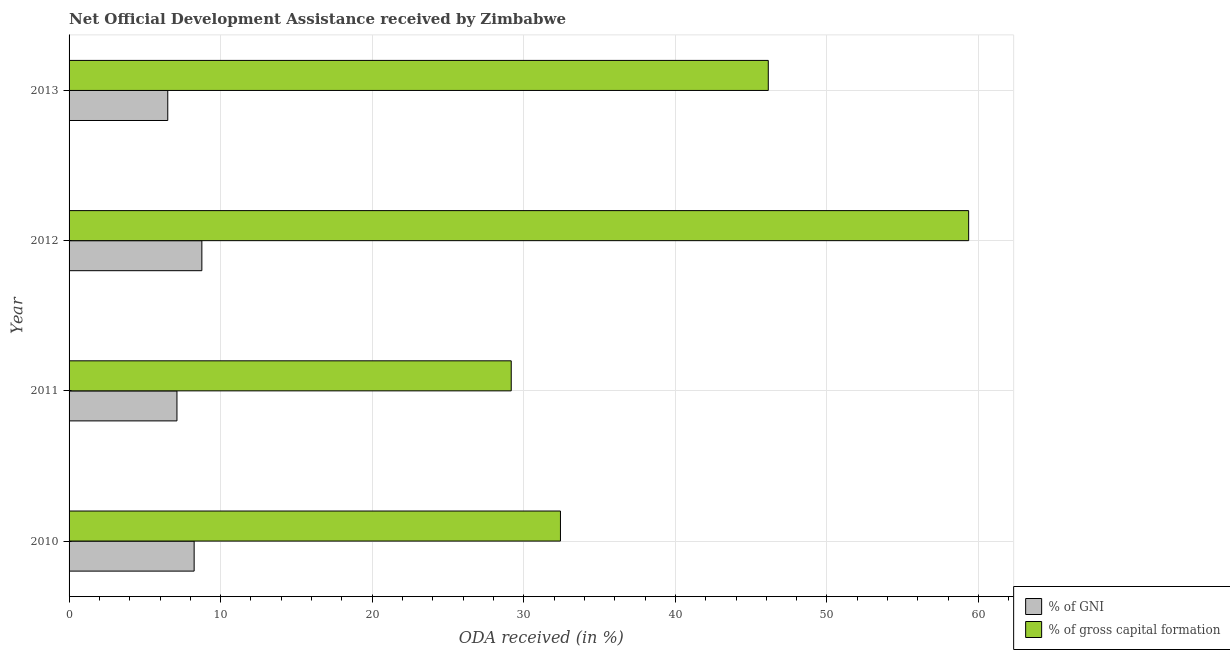How many groups of bars are there?
Make the answer very short. 4. Are the number of bars per tick equal to the number of legend labels?
Your answer should be compact. Yes. How many bars are there on the 1st tick from the bottom?
Your response must be concise. 2. In how many cases, is the number of bars for a given year not equal to the number of legend labels?
Provide a short and direct response. 0. What is the oda received as percentage of gni in 2013?
Make the answer very short. 6.51. Across all years, what is the maximum oda received as percentage of gni?
Provide a short and direct response. 8.76. Across all years, what is the minimum oda received as percentage of gross capital formation?
Provide a succinct answer. 29.17. In which year was the oda received as percentage of gross capital formation maximum?
Your answer should be compact. 2012. In which year was the oda received as percentage of gross capital formation minimum?
Provide a succinct answer. 2011. What is the total oda received as percentage of gross capital formation in the graph?
Give a very brief answer. 167.07. What is the difference between the oda received as percentage of gross capital formation in 2010 and that in 2013?
Keep it short and to the point. -13.71. What is the difference between the oda received as percentage of gross capital formation in 2010 and the oda received as percentage of gni in 2012?
Your answer should be compact. 23.66. What is the average oda received as percentage of gni per year?
Your answer should be very brief. 7.66. In the year 2013, what is the difference between the oda received as percentage of gross capital formation and oda received as percentage of gni?
Offer a terse response. 39.62. In how many years, is the oda received as percentage of gross capital formation greater than 22 %?
Provide a succinct answer. 4. What is the ratio of the oda received as percentage of gni in 2010 to that in 2011?
Give a very brief answer. 1.16. What is the difference between the highest and the second highest oda received as percentage of gni?
Ensure brevity in your answer.  0.51. What is the difference between the highest and the lowest oda received as percentage of gni?
Offer a very short reply. 2.25. Is the sum of the oda received as percentage of gross capital formation in 2010 and 2012 greater than the maximum oda received as percentage of gni across all years?
Offer a very short reply. Yes. What does the 2nd bar from the top in 2010 represents?
Your response must be concise. % of GNI. What does the 2nd bar from the bottom in 2012 represents?
Your answer should be compact. % of gross capital formation. Are all the bars in the graph horizontal?
Offer a terse response. Yes. How many years are there in the graph?
Keep it short and to the point. 4. What is the difference between two consecutive major ticks on the X-axis?
Make the answer very short. 10. Does the graph contain grids?
Offer a very short reply. Yes. What is the title of the graph?
Give a very brief answer. Net Official Development Assistance received by Zimbabwe. Does "All education staff compensation" appear as one of the legend labels in the graph?
Ensure brevity in your answer.  No. What is the label or title of the X-axis?
Provide a succinct answer. ODA received (in %). What is the ODA received (in %) in % of GNI in 2010?
Keep it short and to the point. 8.25. What is the ODA received (in %) in % of gross capital formation in 2010?
Keep it short and to the point. 32.42. What is the ODA received (in %) in % of GNI in 2011?
Your answer should be compact. 7.12. What is the ODA received (in %) in % of gross capital formation in 2011?
Offer a very short reply. 29.17. What is the ODA received (in %) in % of GNI in 2012?
Your answer should be compact. 8.76. What is the ODA received (in %) of % of gross capital formation in 2012?
Offer a terse response. 59.35. What is the ODA received (in %) in % of GNI in 2013?
Your answer should be compact. 6.51. What is the ODA received (in %) in % of gross capital formation in 2013?
Provide a short and direct response. 46.13. Across all years, what is the maximum ODA received (in %) of % of GNI?
Your response must be concise. 8.76. Across all years, what is the maximum ODA received (in %) of % of gross capital formation?
Make the answer very short. 59.35. Across all years, what is the minimum ODA received (in %) of % of GNI?
Give a very brief answer. 6.51. Across all years, what is the minimum ODA received (in %) of % of gross capital formation?
Provide a succinct answer. 29.17. What is the total ODA received (in %) of % of GNI in the graph?
Your answer should be very brief. 30.64. What is the total ODA received (in %) in % of gross capital formation in the graph?
Provide a succinct answer. 167.07. What is the difference between the ODA received (in %) in % of GNI in 2010 and that in 2011?
Make the answer very short. 1.13. What is the difference between the ODA received (in %) of % of gross capital formation in 2010 and that in 2011?
Provide a short and direct response. 3.25. What is the difference between the ODA received (in %) of % of GNI in 2010 and that in 2012?
Your answer should be compact. -0.51. What is the difference between the ODA received (in %) in % of gross capital formation in 2010 and that in 2012?
Offer a very short reply. -26.93. What is the difference between the ODA received (in %) in % of GNI in 2010 and that in 2013?
Keep it short and to the point. 1.74. What is the difference between the ODA received (in %) in % of gross capital formation in 2010 and that in 2013?
Ensure brevity in your answer.  -13.71. What is the difference between the ODA received (in %) of % of GNI in 2011 and that in 2012?
Your answer should be compact. -1.64. What is the difference between the ODA received (in %) of % of gross capital formation in 2011 and that in 2012?
Your answer should be compact. -30.18. What is the difference between the ODA received (in %) in % of GNI in 2011 and that in 2013?
Your answer should be compact. 0.61. What is the difference between the ODA received (in %) of % of gross capital formation in 2011 and that in 2013?
Provide a succinct answer. -16.96. What is the difference between the ODA received (in %) of % of GNI in 2012 and that in 2013?
Keep it short and to the point. 2.25. What is the difference between the ODA received (in %) in % of gross capital formation in 2012 and that in 2013?
Offer a very short reply. 13.22. What is the difference between the ODA received (in %) of % of GNI in 2010 and the ODA received (in %) of % of gross capital formation in 2011?
Offer a terse response. -20.92. What is the difference between the ODA received (in %) of % of GNI in 2010 and the ODA received (in %) of % of gross capital formation in 2012?
Offer a terse response. -51.1. What is the difference between the ODA received (in %) in % of GNI in 2010 and the ODA received (in %) in % of gross capital formation in 2013?
Give a very brief answer. -37.88. What is the difference between the ODA received (in %) of % of GNI in 2011 and the ODA received (in %) of % of gross capital formation in 2012?
Ensure brevity in your answer.  -52.23. What is the difference between the ODA received (in %) of % of GNI in 2011 and the ODA received (in %) of % of gross capital formation in 2013?
Ensure brevity in your answer.  -39.01. What is the difference between the ODA received (in %) of % of GNI in 2012 and the ODA received (in %) of % of gross capital formation in 2013?
Provide a succinct answer. -37.37. What is the average ODA received (in %) of % of GNI per year?
Make the answer very short. 7.66. What is the average ODA received (in %) of % of gross capital formation per year?
Ensure brevity in your answer.  41.77. In the year 2010, what is the difference between the ODA received (in %) of % of GNI and ODA received (in %) of % of gross capital formation?
Your answer should be very brief. -24.17. In the year 2011, what is the difference between the ODA received (in %) of % of GNI and ODA received (in %) of % of gross capital formation?
Offer a very short reply. -22.05. In the year 2012, what is the difference between the ODA received (in %) of % of GNI and ODA received (in %) of % of gross capital formation?
Give a very brief answer. -50.59. In the year 2013, what is the difference between the ODA received (in %) in % of GNI and ODA received (in %) in % of gross capital formation?
Offer a very short reply. -39.62. What is the ratio of the ODA received (in %) in % of GNI in 2010 to that in 2011?
Offer a terse response. 1.16. What is the ratio of the ODA received (in %) of % of gross capital formation in 2010 to that in 2011?
Keep it short and to the point. 1.11. What is the ratio of the ODA received (in %) of % of GNI in 2010 to that in 2012?
Keep it short and to the point. 0.94. What is the ratio of the ODA received (in %) in % of gross capital formation in 2010 to that in 2012?
Offer a terse response. 0.55. What is the ratio of the ODA received (in %) of % of GNI in 2010 to that in 2013?
Your answer should be very brief. 1.27. What is the ratio of the ODA received (in %) in % of gross capital formation in 2010 to that in 2013?
Give a very brief answer. 0.7. What is the ratio of the ODA received (in %) of % of GNI in 2011 to that in 2012?
Ensure brevity in your answer.  0.81. What is the ratio of the ODA received (in %) of % of gross capital formation in 2011 to that in 2012?
Ensure brevity in your answer.  0.49. What is the ratio of the ODA received (in %) of % of GNI in 2011 to that in 2013?
Keep it short and to the point. 1.09. What is the ratio of the ODA received (in %) in % of gross capital formation in 2011 to that in 2013?
Provide a succinct answer. 0.63. What is the ratio of the ODA received (in %) in % of GNI in 2012 to that in 2013?
Give a very brief answer. 1.35. What is the ratio of the ODA received (in %) of % of gross capital formation in 2012 to that in 2013?
Make the answer very short. 1.29. What is the difference between the highest and the second highest ODA received (in %) in % of GNI?
Offer a very short reply. 0.51. What is the difference between the highest and the second highest ODA received (in %) in % of gross capital formation?
Offer a very short reply. 13.22. What is the difference between the highest and the lowest ODA received (in %) in % of GNI?
Make the answer very short. 2.25. What is the difference between the highest and the lowest ODA received (in %) in % of gross capital formation?
Your answer should be very brief. 30.18. 